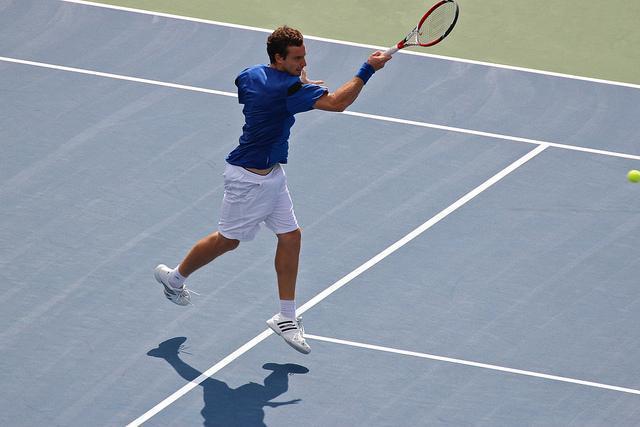How many surfboards are there?
Give a very brief answer. 0. 